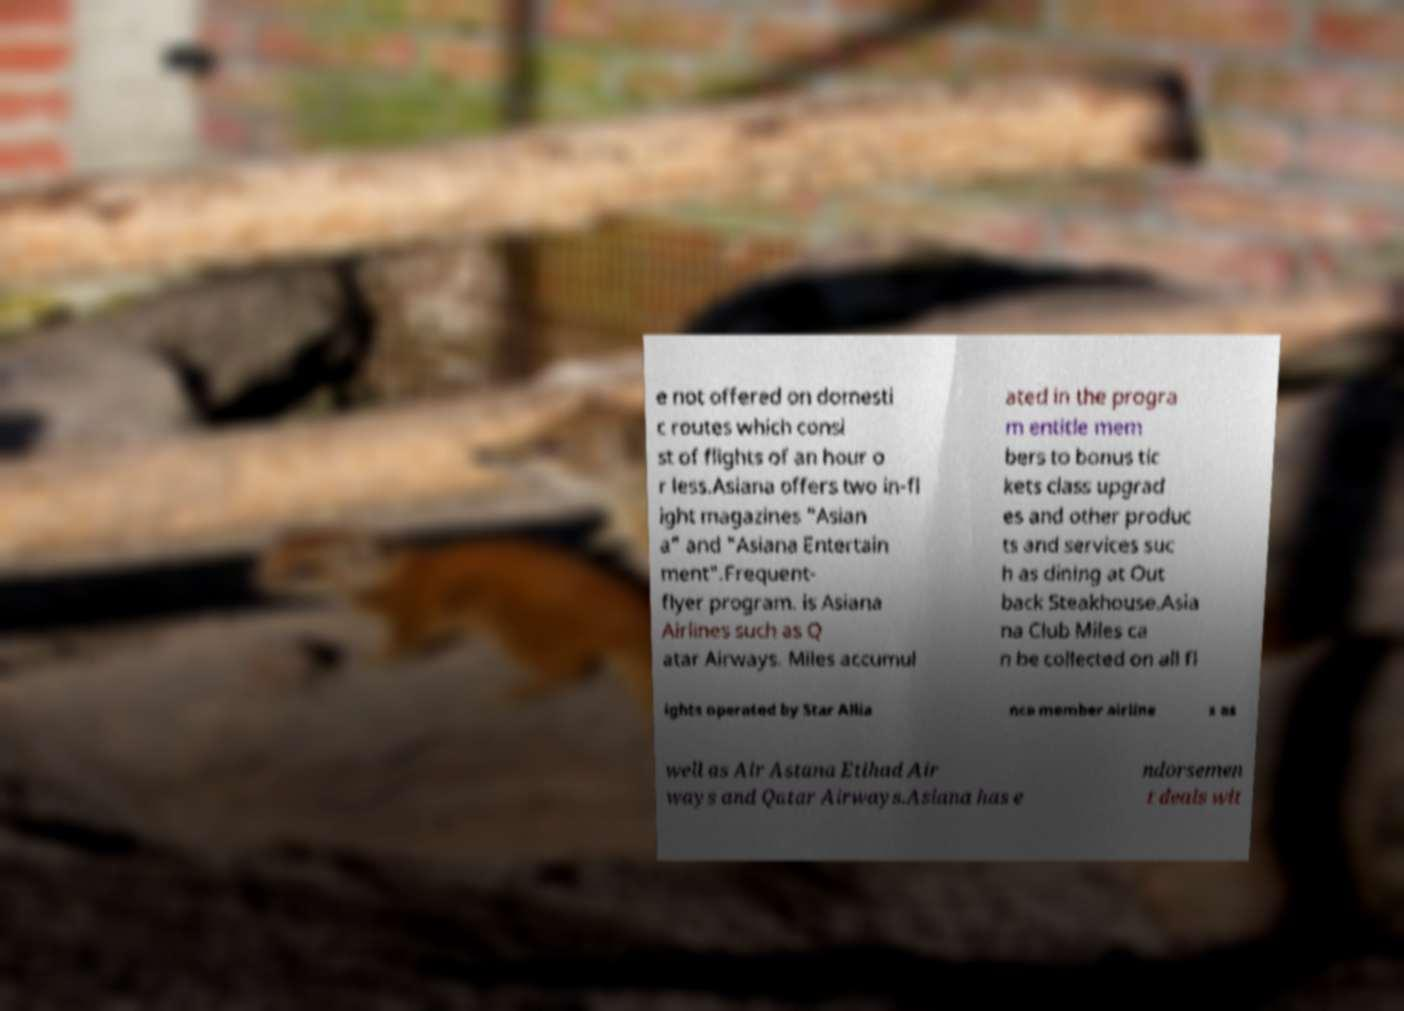Please read and relay the text visible in this image. What does it say? e not offered on domesti c routes which consi st of flights of an hour o r less.Asiana offers two in-fl ight magazines "Asian a" and "Asiana Entertain ment".Frequent- flyer program. is Asiana Airlines such as Q atar Airways. Miles accumul ated in the progra m entitle mem bers to bonus tic kets class upgrad es and other produc ts and services suc h as dining at Out back Steakhouse.Asia na Club Miles ca n be collected on all fl ights operated by Star Allia nce member airline s as well as Air Astana Etihad Air ways and Qatar Airways.Asiana has e ndorsemen t deals wit 